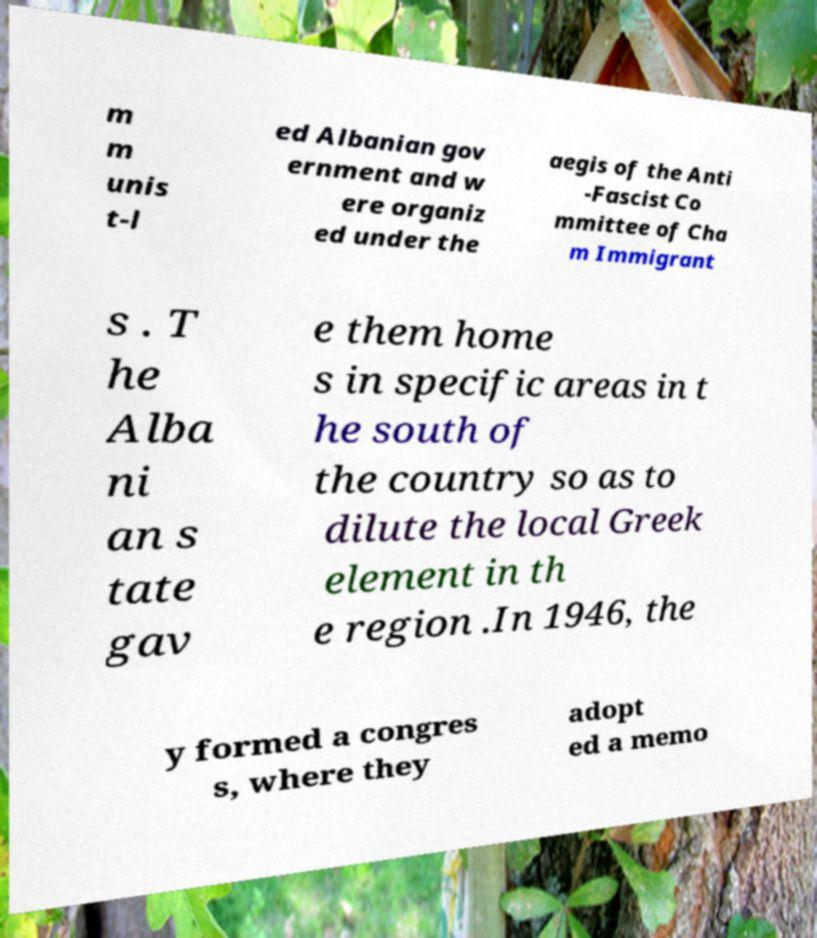Could you assist in decoding the text presented in this image and type it out clearly? m m unis t-l ed Albanian gov ernment and w ere organiz ed under the aegis of the Anti -Fascist Co mmittee of Cha m Immigrant s . T he Alba ni an s tate gav e them home s in specific areas in t he south of the country so as to dilute the local Greek element in th e region .In 1946, the y formed a congres s, where they adopt ed a memo 